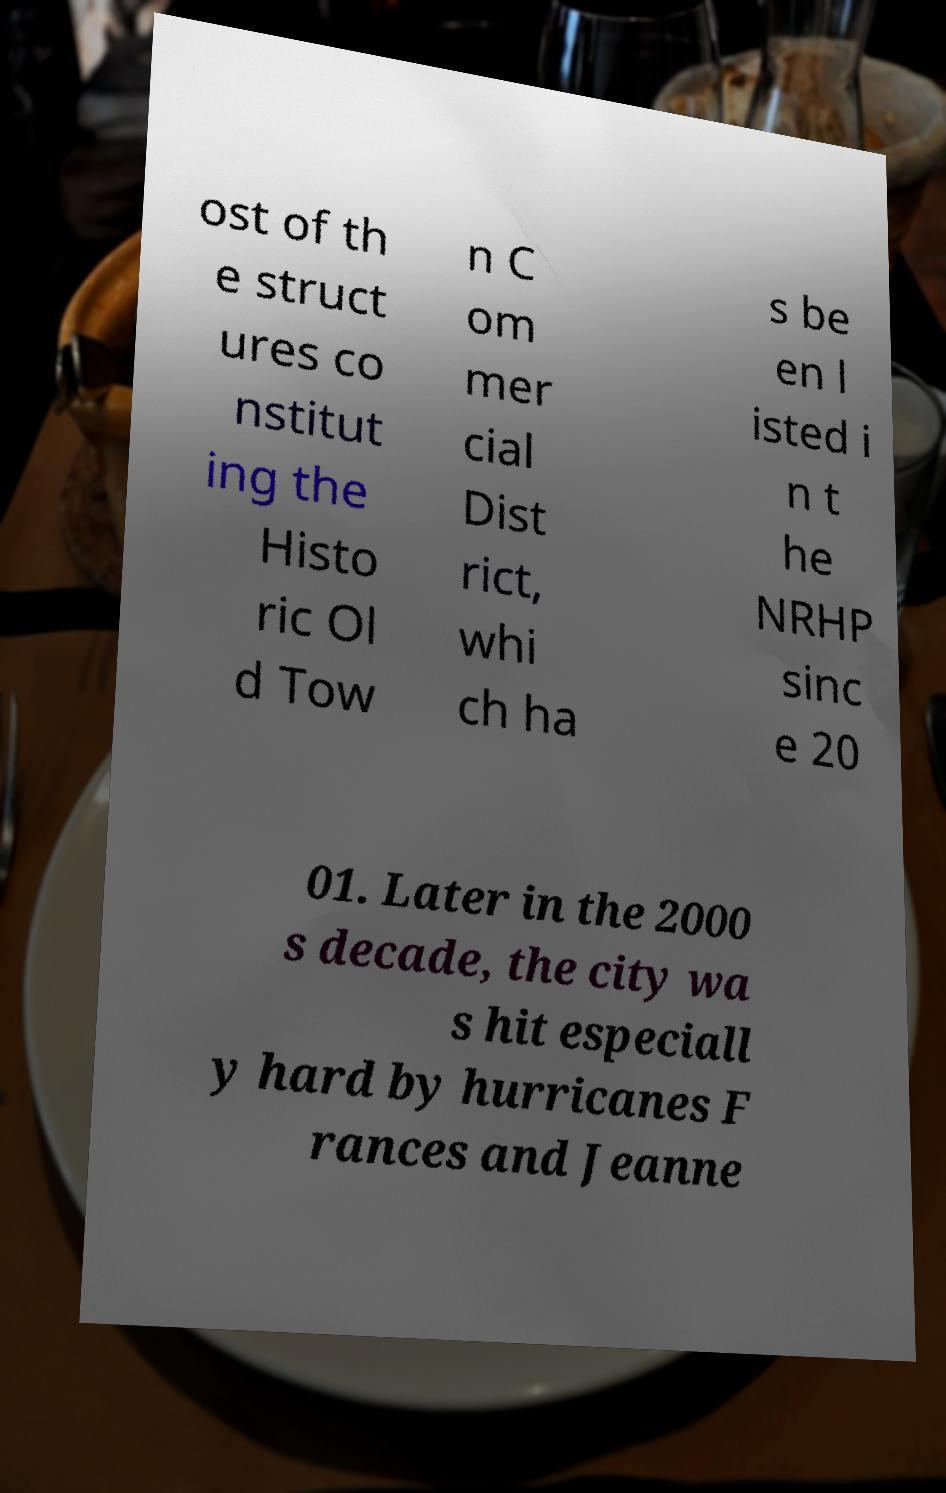Please read and relay the text visible in this image. What does it say? ost of th e struct ures co nstitut ing the Histo ric Ol d Tow n C om mer cial Dist rict, whi ch ha s be en l isted i n t he NRHP sinc e 20 01. Later in the 2000 s decade, the city wa s hit especiall y hard by hurricanes F rances and Jeanne 